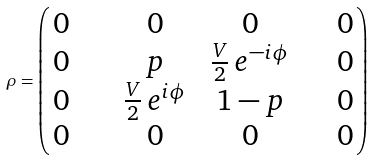<formula> <loc_0><loc_0><loc_500><loc_500>\rho = \left ( \, \begin{matrix} 0 \quad & \quad 0 \quad & \quad 0 \quad & \quad 0 \\ 0 \quad & p & \frac { V } { 2 } \, e ^ { - i \phi } & \quad 0 \\ 0 \quad & \frac { V } { 2 } \, e ^ { i \phi } & 1 - p & \quad 0 \\ 0 \quad & 0 & 0 & \quad 0 \end{matrix} \, \right )</formula> 